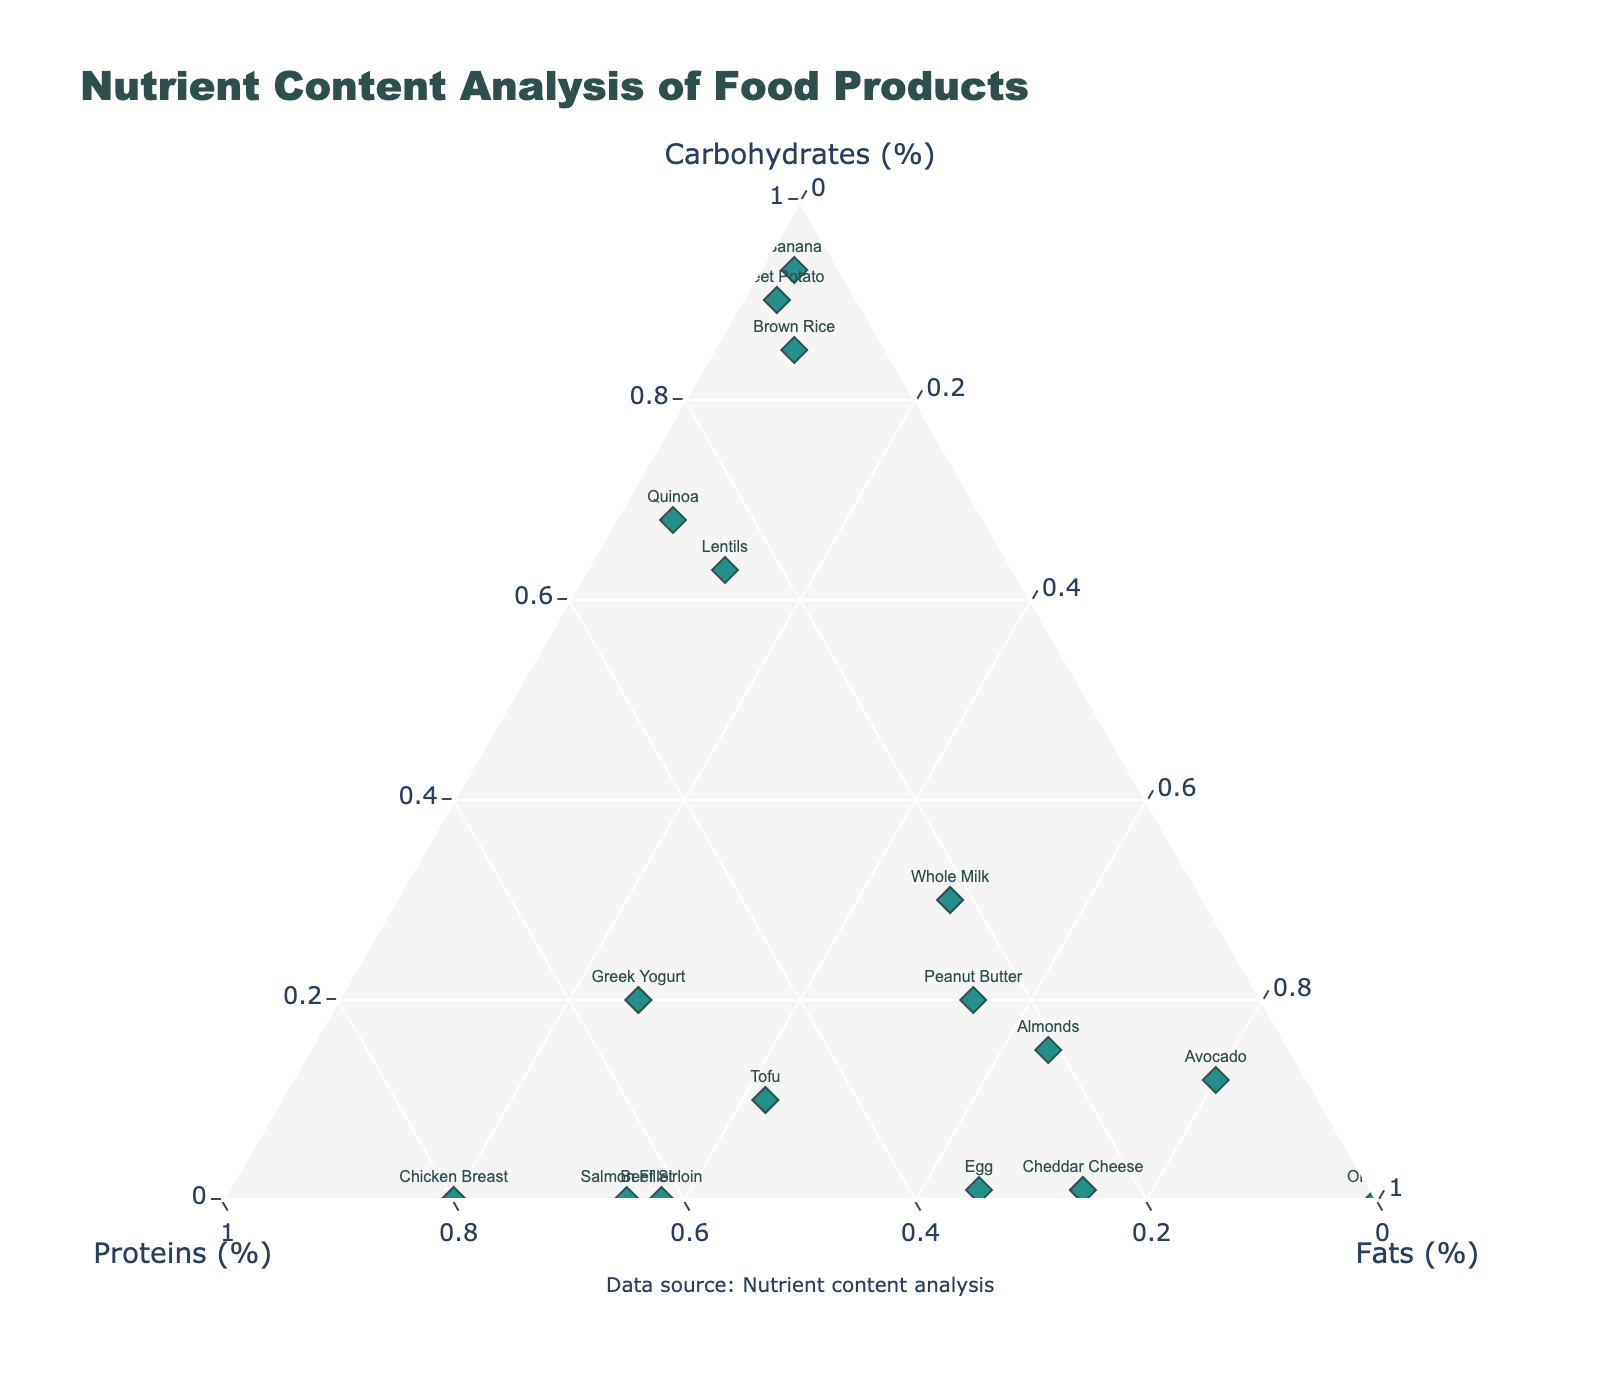What is the title of the plot? The title is usually displayed at the top of the figure to give a brief idea of what the plot is about. In this case, you can find it at the top, labeled in bigger text.
Answer: Nutrient Content Analysis of Food Products How many foods have protein content greater than carbohydrate content? To answer this, scan the plot for points that are inclined more towards the "Proteins (%)" axis than the "Carbohydrates (%)" axis. Count these data points.
Answer: 8 Which food product has the highest fat percentage? Locate the point that is positioned closest to the "Fats (%)" vertex, which indicates that it has the highest proportion of fats.
Answer: Olive Oil Which food product has the highest carbohydrate percentage? Look for the data point that is positioned closest to the "Carbohydrates (%)" vertex, indicating the highest proportion of carbohydrates.
Answer: Banana Which food product is positioned closest to the centroid (equal proportions of all nutrients)? The centroid of a ternary plot represents equal proportions (33.3% each) of carbohydrates, proteins, and fats. Identify the point that is nearest to this central position.
Answer: Whole Milk Between Cheddar Cheese and Eggs, which has a higher fat percentage and by how much? Identify both points on the plot. Cheddar Cheese is closer to the "Fats (%)" vertex than Eggs. Compare the difference in their positions along the "Fats (%)" axis. Cheddar Cheese has 74% fats, while Eggs have 65% fats. The difference is 74% - 65%.
Answer: Cheddar Cheese by 9% Which food products have no carbohydrate content? Identify any data points lying along the "Proteins-Fats" edge without any contribution from the "Carbohydrates (%)" vertex. Scan the plot for such points.
Answer: Salmon Fillet, Chicken Breast, Olive Oil, Beef Sirloin What is the difference in the protein content between Lentils and Greek Yogurt? Locate the points representing Lentils and Greek Yogurt. Lentils' normalized protein content is 25%, and Greek Yogurt's normalized protein content is 54%. Compute the difference: 54% - 25%.
Answer: 29% Is there a food product that contains equal proportions of carbohydrates and fats? Locate any data point on the ternary plot that has an equal distance to both the "Carbohydrates (%)" and "Fats (%)" vertices, meaning the percentages for carbohydrates and fats are the same.
Answer: No What is the average carbohydrate content of Quinoa, Brown Rice, and Sweet Potato? Find the positions representing Quinoa (68%), Brown Rice (85%), and Sweet Potato (90%). Compute the average: (68 + 85 + 90) / 3.
Answer: 81% Which food product has the most balanced nutrient composition between carbohydrates, proteins, and fats? Identify the point closest to the center of the plot where the contributions of carbohydrates, proteins, and fats are the most balanced. It’s typically a point where these nutrients are almost equal.
Answer: Whole Milk 